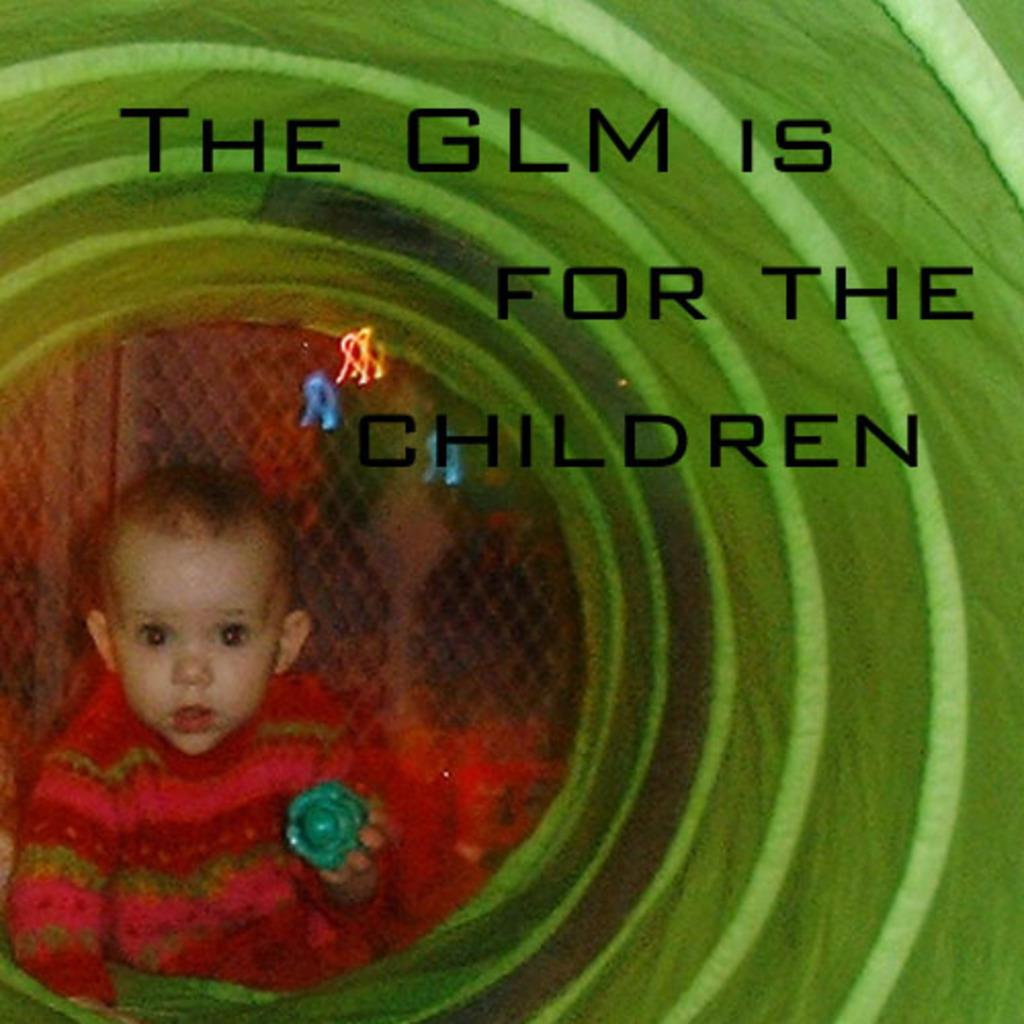What is the main subject of the image? There is a baby in the image. Where is the baby located? The baby is sitting in a plastic container. What is the baby holding in the image? The baby is holding an object. Can you describe any text visible in the image? Yes, there is text visible in the image. What type of coat is the baby wearing in the image? There is no coat visible in the image; the baby is sitting in a plastic container. 